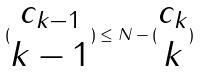Convert formula to latex. <formula><loc_0><loc_0><loc_500><loc_500>( \begin{matrix} c _ { k - 1 } \\ k - 1 \end{matrix} ) \leq N - ( \begin{matrix} c _ { k } \\ k \end{matrix} )</formula> 